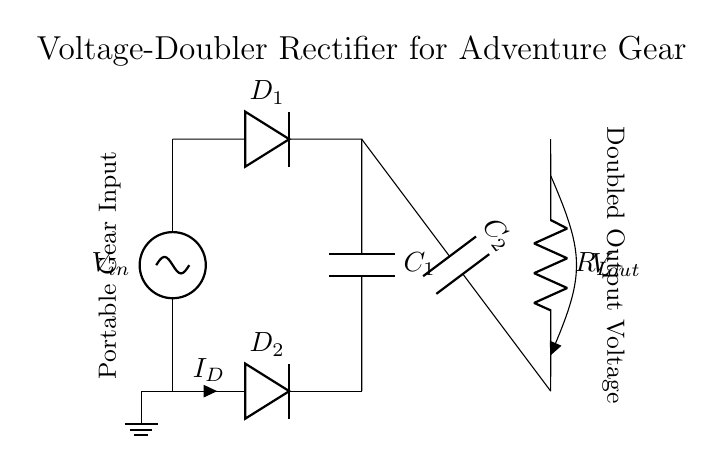What is the purpose of D1? D1 is a diode that allows current to flow in one direction only, preventing any backflow. In this circuit, it serves to rectify the AC input voltage to a DC voltage.
Answer: Rectification What does C1 do in the circuit? C1 is a capacitor that stores energy. It charges when the diode D1 is conducting and discharges into the load when D1 is off, smoothing the output voltage.
Answer: Energy storage How many diodes are in the circuit? There are two diodes (D1 and D2) present in the voltage-doubler rectifier circuit.
Answer: Two What is the output voltage in relation to the input voltage? The output voltage is approximately double the input voltage, due to the capacitive charging and the arrangement of diodes in a voltage-doubler setup.
Answer: Double What type of load is represented by R_L? R_L represents a resistive load, which is the component that consumes the output power from the rectifier circuit.
Answer: Resistive load Why are there two capacitors in this circuit? The two capacitors (C1 and C2) work together in the voltage-doubling process. C1 charges from the input voltage, and C2 adds its charge to C1's charge, effectively doubling the voltage seen by the load.
Answer: Voltage doubling 